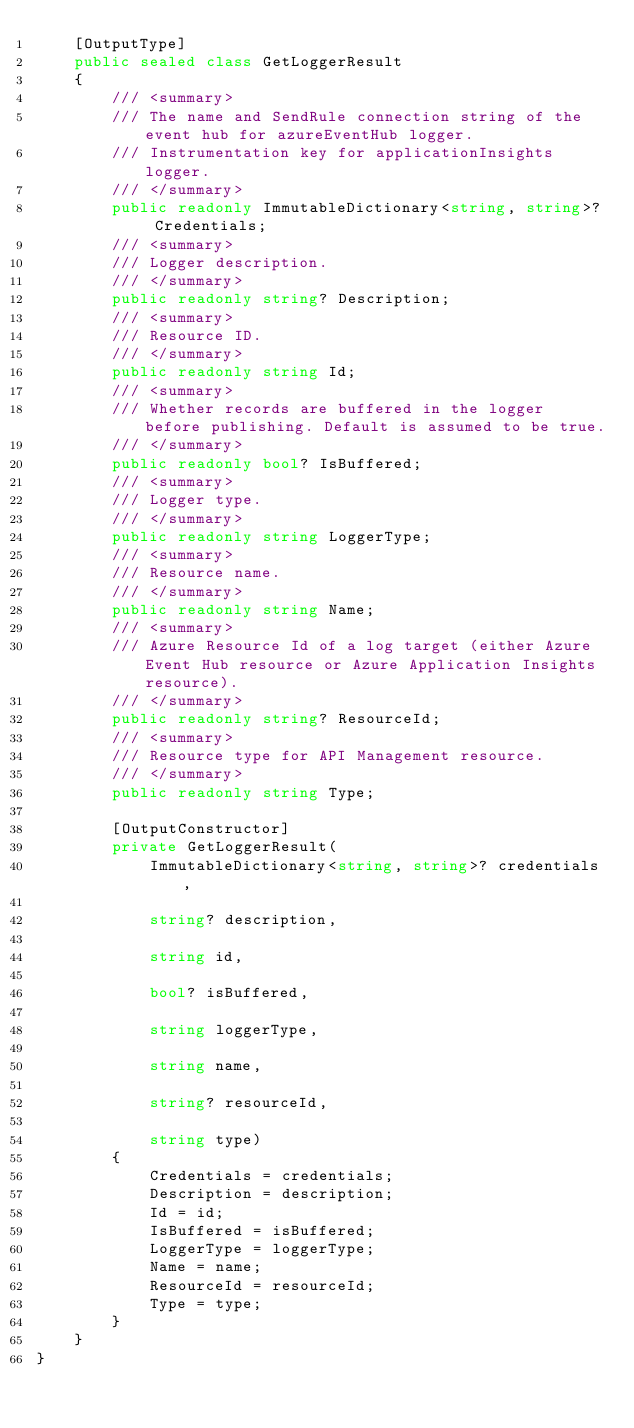<code> <loc_0><loc_0><loc_500><loc_500><_C#_>    [OutputType]
    public sealed class GetLoggerResult
    {
        /// <summary>
        /// The name and SendRule connection string of the event hub for azureEventHub logger.
        /// Instrumentation key for applicationInsights logger.
        /// </summary>
        public readonly ImmutableDictionary<string, string>? Credentials;
        /// <summary>
        /// Logger description.
        /// </summary>
        public readonly string? Description;
        /// <summary>
        /// Resource ID.
        /// </summary>
        public readonly string Id;
        /// <summary>
        /// Whether records are buffered in the logger before publishing. Default is assumed to be true.
        /// </summary>
        public readonly bool? IsBuffered;
        /// <summary>
        /// Logger type.
        /// </summary>
        public readonly string LoggerType;
        /// <summary>
        /// Resource name.
        /// </summary>
        public readonly string Name;
        /// <summary>
        /// Azure Resource Id of a log target (either Azure Event Hub resource or Azure Application Insights resource).
        /// </summary>
        public readonly string? ResourceId;
        /// <summary>
        /// Resource type for API Management resource.
        /// </summary>
        public readonly string Type;

        [OutputConstructor]
        private GetLoggerResult(
            ImmutableDictionary<string, string>? credentials,

            string? description,

            string id,

            bool? isBuffered,

            string loggerType,

            string name,

            string? resourceId,

            string type)
        {
            Credentials = credentials;
            Description = description;
            Id = id;
            IsBuffered = isBuffered;
            LoggerType = loggerType;
            Name = name;
            ResourceId = resourceId;
            Type = type;
        }
    }
}
</code> 